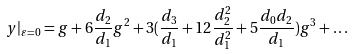<formula> <loc_0><loc_0><loc_500><loc_500>y | _ { \varepsilon = 0 } = g + 6 \frac { d _ { 2 } } { d _ { 1 } } g ^ { 2 } + 3 ( \frac { d _ { 3 } } { d _ { 1 } } + 1 2 \frac { d _ { 2 } ^ { 2 } } { d _ { 1 } ^ { 2 } } + 5 \frac { d _ { 0 } d _ { 2 } } { d _ { 1 } } ) g ^ { 3 } + \dots</formula> 